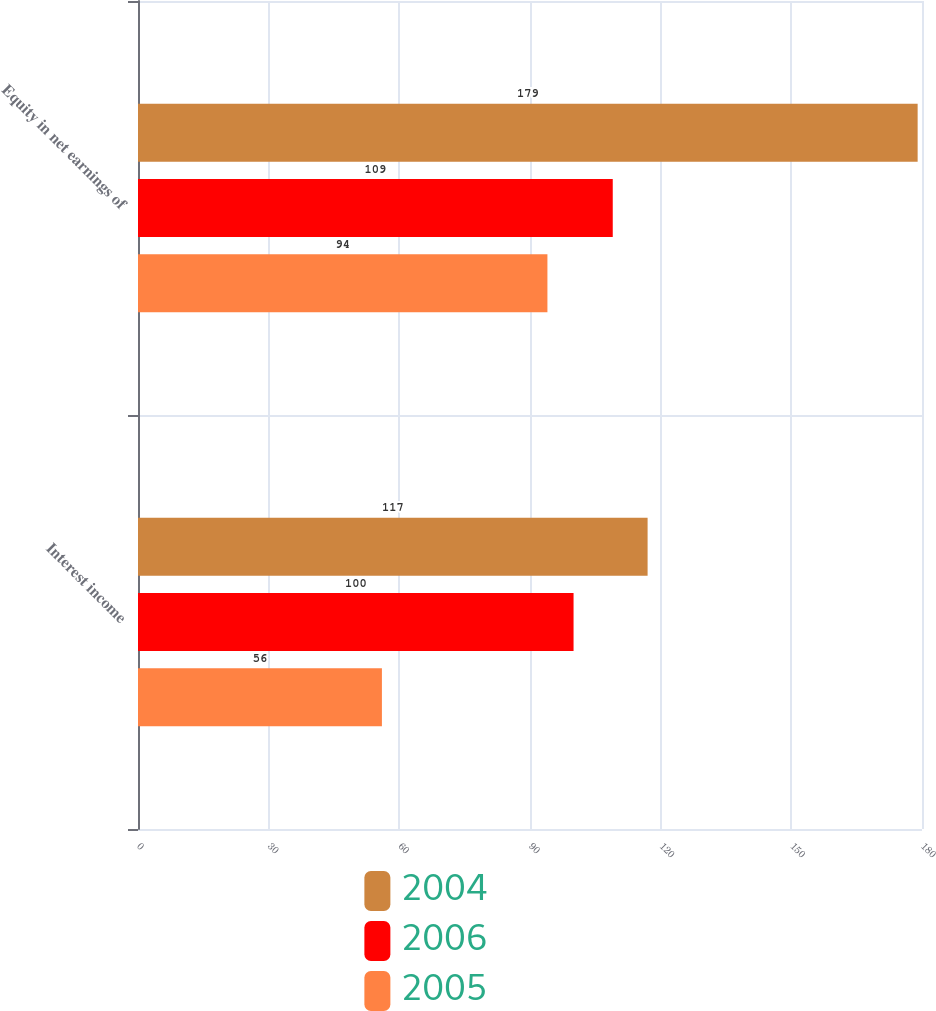Convert chart. <chart><loc_0><loc_0><loc_500><loc_500><stacked_bar_chart><ecel><fcel>Interest income<fcel>Equity in net earnings of<nl><fcel>2004<fcel>117<fcel>179<nl><fcel>2006<fcel>100<fcel>109<nl><fcel>2005<fcel>56<fcel>94<nl></chart> 